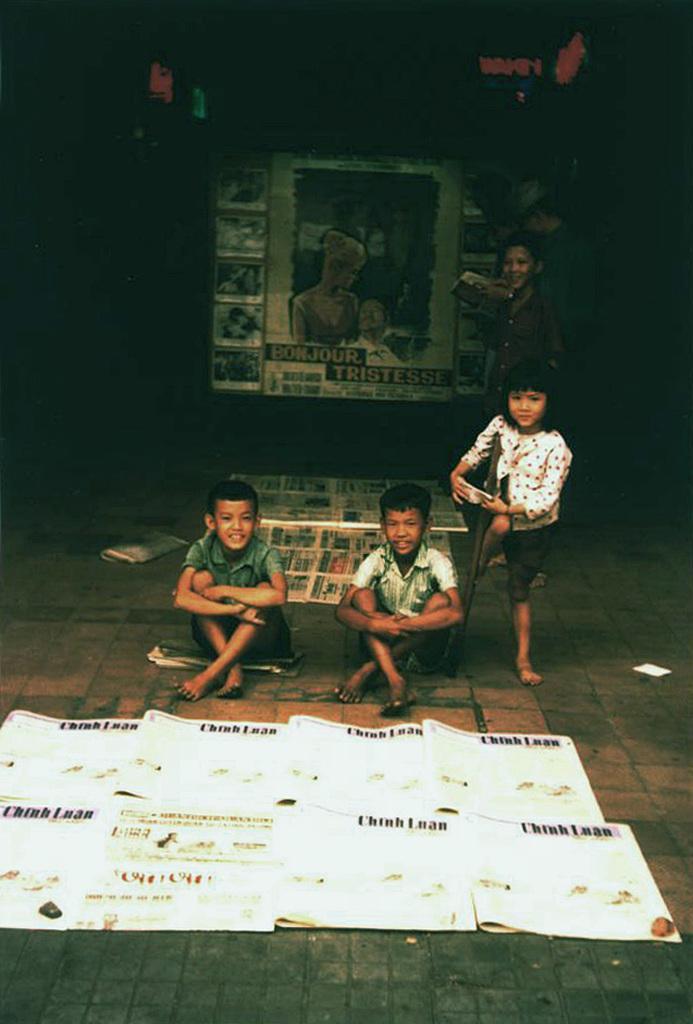In one or two sentences, can you explain what this image depicts? This image consists of few persons. At the bottom, we can see the papers on the ground. In the background, it looks like a poster on the wall. The background is too dark. At the bottom, there is a road. 